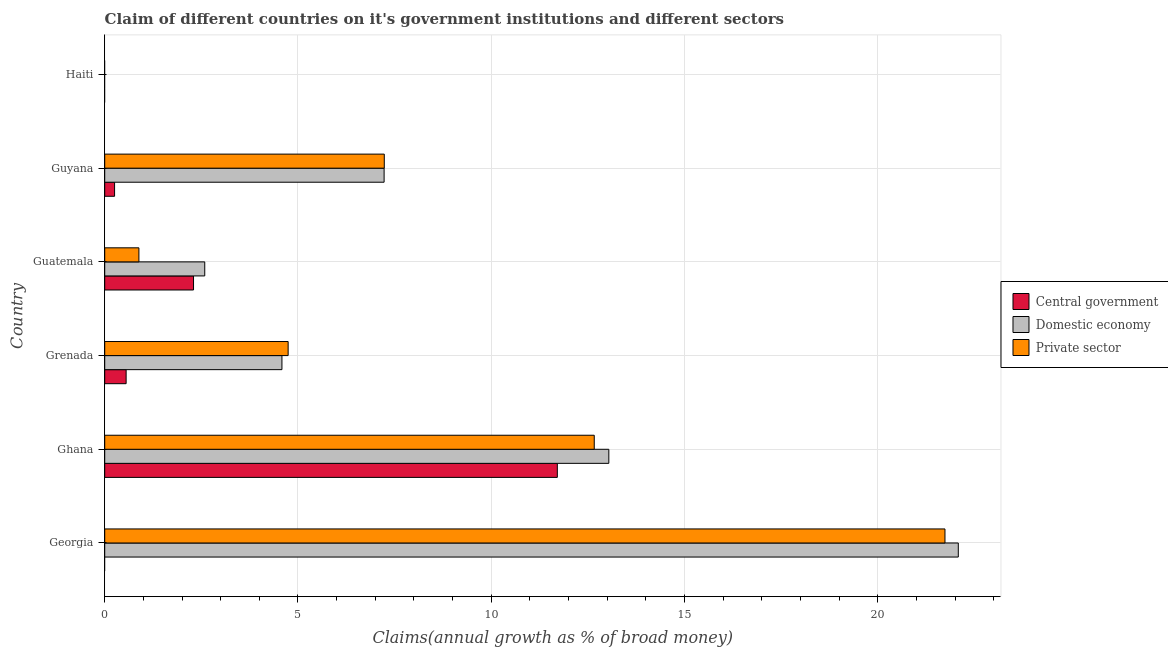How many different coloured bars are there?
Provide a short and direct response. 3. Are the number of bars on each tick of the Y-axis equal?
Your answer should be very brief. No. What is the label of the 2nd group of bars from the top?
Keep it short and to the point. Guyana. What is the percentage of claim on the central government in Haiti?
Your answer should be very brief. 0. Across all countries, what is the maximum percentage of claim on the private sector?
Offer a very short reply. 21.74. Across all countries, what is the minimum percentage of claim on the private sector?
Keep it short and to the point. 0. In which country was the percentage of claim on the private sector maximum?
Ensure brevity in your answer.  Georgia. What is the total percentage of claim on the private sector in the graph?
Make the answer very short. 47.27. What is the difference between the percentage of claim on the private sector in Ghana and that in Guyana?
Your answer should be compact. 5.43. What is the difference between the percentage of claim on the private sector in Grenada and the percentage of claim on the domestic economy in Georgia?
Ensure brevity in your answer.  -17.34. What is the average percentage of claim on the private sector per country?
Keep it short and to the point. 7.88. What is the difference between the percentage of claim on the private sector and percentage of claim on the central government in Grenada?
Provide a succinct answer. 4.19. What is the ratio of the percentage of claim on the domestic economy in Grenada to that in Guatemala?
Your answer should be compact. 1.77. Is the percentage of claim on the domestic economy in Ghana less than that in Guatemala?
Your answer should be compact. No. What is the difference between the highest and the second highest percentage of claim on the central government?
Your answer should be compact. 9.41. What is the difference between the highest and the lowest percentage of claim on the private sector?
Give a very brief answer. 21.74. In how many countries, is the percentage of claim on the private sector greater than the average percentage of claim on the private sector taken over all countries?
Provide a short and direct response. 2. Is it the case that in every country, the sum of the percentage of claim on the central government and percentage of claim on the domestic economy is greater than the percentage of claim on the private sector?
Your answer should be very brief. No. Are all the bars in the graph horizontal?
Keep it short and to the point. Yes. How many countries are there in the graph?
Provide a short and direct response. 6. Are the values on the major ticks of X-axis written in scientific E-notation?
Keep it short and to the point. No. Does the graph contain grids?
Provide a succinct answer. Yes. How many legend labels are there?
Your response must be concise. 3. What is the title of the graph?
Keep it short and to the point. Claim of different countries on it's government institutions and different sectors. Does "Refusal of sex" appear as one of the legend labels in the graph?
Make the answer very short. No. What is the label or title of the X-axis?
Offer a terse response. Claims(annual growth as % of broad money). What is the label or title of the Y-axis?
Offer a very short reply. Country. What is the Claims(annual growth as % of broad money) of Central government in Georgia?
Your answer should be compact. 0. What is the Claims(annual growth as % of broad money) in Domestic economy in Georgia?
Give a very brief answer. 22.08. What is the Claims(annual growth as % of broad money) in Private sector in Georgia?
Ensure brevity in your answer.  21.74. What is the Claims(annual growth as % of broad money) in Central government in Ghana?
Your answer should be compact. 11.71. What is the Claims(annual growth as % of broad money) of Domestic economy in Ghana?
Provide a succinct answer. 13.04. What is the Claims(annual growth as % of broad money) in Private sector in Ghana?
Your answer should be very brief. 12.66. What is the Claims(annual growth as % of broad money) of Central government in Grenada?
Offer a terse response. 0.55. What is the Claims(annual growth as % of broad money) of Domestic economy in Grenada?
Your answer should be compact. 4.58. What is the Claims(annual growth as % of broad money) in Private sector in Grenada?
Keep it short and to the point. 4.75. What is the Claims(annual growth as % of broad money) in Central government in Guatemala?
Make the answer very short. 2.3. What is the Claims(annual growth as % of broad money) of Domestic economy in Guatemala?
Offer a terse response. 2.59. What is the Claims(annual growth as % of broad money) in Private sector in Guatemala?
Provide a succinct answer. 0.88. What is the Claims(annual growth as % of broad money) of Central government in Guyana?
Keep it short and to the point. 0.25. What is the Claims(annual growth as % of broad money) of Domestic economy in Guyana?
Ensure brevity in your answer.  7.23. What is the Claims(annual growth as % of broad money) in Private sector in Guyana?
Ensure brevity in your answer.  7.23. What is the Claims(annual growth as % of broad money) of Private sector in Haiti?
Your answer should be very brief. 0. Across all countries, what is the maximum Claims(annual growth as % of broad money) of Central government?
Give a very brief answer. 11.71. Across all countries, what is the maximum Claims(annual growth as % of broad money) in Domestic economy?
Make the answer very short. 22.08. Across all countries, what is the maximum Claims(annual growth as % of broad money) in Private sector?
Make the answer very short. 21.74. Across all countries, what is the minimum Claims(annual growth as % of broad money) of Central government?
Your answer should be compact. 0. What is the total Claims(annual growth as % of broad money) of Central government in the graph?
Your response must be concise. 14.82. What is the total Claims(annual growth as % of broad money) of Domestic economy in the graph?
Offer a terse response. 49.53. What is the total Claims(annual growth as % of broad money) in Private sector in the graph?
Your answer should be compact. 47.27. What is the difference between the Claims(annual growth as % of broad money) in Domestic economy in Georgia and that in Ghana?
Offer a terse response. 9.04. What is the difference between the Claims(annual growth as % of broad money) of Private sector in Georgia and that in Ghana?
Offer a very short reply. 9.07. What is the difference between the Claims(annual growth as % of broad money) of Domestic economy in Georgia and that in Grenada?
Give a very brief answer. 17.5. What is the difference between the Claims(annual growth as % of broad money) in Private sector in Georgia and that in Grenada?
Provide a short and direct response. 16.99. What is the difference between the Claims(annual growth as % of broad money) of Domestic economy in Georgia and that in Guatemala?
Offer a terse response. 19.49. What is the difference between the Claims(annual growth as % of broad money) of Private sector in Georgia and that in Guatemala?
Offer a terse response. 20.85. What is the difference between the Claims(annual growth as % of broad money) in Domestic economy in Georgia and that in Guyana?
Ensure brevity in your answer.  14.85. What is the difference between the Claims(annual growth as % of broad money) of Private sector in Georgia and that in Guyana?
Offer a very short reply. 14.51. What is the difference between the Claims(annual growth as % of broad money) in Central government in Ghana and that in Grenada?
Provide a succinct answer. 11.16. What is the difference between the Claims(annual growth as % of broad money) in Domestic economy in Ghana and that in Grenada?
Make the answer very short. 8.46. What is the difference between the Claims(annual growth as % of broad money) of Private sector in Ghana and that in Grenada?
Provide a short and direct response. 7.92. What is the difference between the Claims(annual growth as % of broad money) in Central government in Ghana and that in Guatemala?
Keep it short and to the point. 9.41. What is the difference between the Claims(annual growth as % of broad money) of Domestic economy in Ghana and that in Guatemala?
Offer a very short reply. 10.45. What is the difference between the Claims(annual growth as % of broad money) in Private sector in Ghana and that in Guatemala?
Your answer should be very brief. 11.78. What is the difference between the Claims(annual growth as % of broad money) of Central government in Ghana and that in Guyana?
Your answer should be very brief. 11.45. What is the difference between the Claims(annual growth as % of broad money) of Domestic economy in Ghana and that in Guyana?
Offer a very short reply. 5.81. What is the difference between the Claims(annual growth as % of broad money) in Private sector in Ghana and that in Guyana?
Ensure brevity in your answer.  5.43. What is the difference between the Claims(annual growth as % of broad money) in Central government in Grenada and that in Guatemala?
Offer a very short reply. -1.74. What is the difference between the Claims(annual growth as % of broad money) of Domestic economy in Grenada and that in Guatemala?
Offer a very short reply. 2. What is the difference between the Claims(annual growth as % of broad money) in Private sector in Grenada and that in Guatemala?
Your answer should be compact. 3.86. What is the difference between the Claims(annual growth as % of broad money) in Central government in Grenada and that in Guyana?
Your response must be concise. 0.3. What is the difference between the Claims(annual growth as % of broad money) in Domestic economy in Grenada and that in Guyana?
Offer a terse response. -2.64. What is the difference between the Claims(annual growth as % of broad money) in Private sector in Grenada and that in Guyana?
Your answer should be very brief. -2.49. What is the difference between the Claims(annual growth as % of broad money) of Central government in Guatemala and that in Guyana?
Make the answer very short. 2.04. What is the difference between the Claims(annual growth as % of broad money) of Domestic economy in Guatemala and that in Guyana?
Ensure brevity in your answer.  -4.64. What is the difference between the Claims(annual growth as % of broad money) of Private sector in Guatemala and that in Guyana?
Your response must be concise. -6.35. What is the difference between the Claims(annual growth as % of broad money) in Domestic economy in Georgia and the Claims(annual growth as % of broad money) in Private sector in Ghana?
Make the answer very short. 9.42. What is the difference between the Claims(annual growth as % of broad money) in Domestic economy in Georgia and the Claims(annual growth as % of broad money) in Private sector in Grenada?
Your response must be concise. 17.34. What is the difference between the Claims(annual growth as % of broad money) in Domestic economy in Georgia and the Claims(annual growth as % of broad money) in Private sector in Guatemala?
Offer a very short reply. 21.2. What is the difference between the Claims(annual growth as % of broad money) in Domestic economy in Georgia and the Claims(annual growth as % of broad money) in Private sector in Guyana?
Offer a very short reply. 14.85. What is the difference between the Claims(annual growth as % of broad money) of Central government in Ghana and the Claims(annual growth as % of broad money) of Domestic economy in Grenada?
Keep it short and to the point. 7.12. What is the difference between the Claims(annual growth as % of broad money) of Central government in Ghana and the Claims(annual growth as % of broad money) of Private sector in Grenada?
Offer a terse response. 6.96. What is the difference between the Claims(annual growth as % of broad money) in Domestic economy in Ghana and the Claims(annual growth as % of broad money) in Private sector in Grenada?
Offer a terse response. 8.3. What is the difference between the Claims(annual growth as % of broad money) of Central government in Ghana and the Claims(annual growth as % of broad money) of Domestic economy in Guatemala?
Offer a terse response. 9.12. What is the difference between the Claims(annual growth as % of broad money) in Central government in Ghana and the Claims(annual growth as % of broad money) in Private sector in Guatemala?
Offer a terse response. 10.82. What is the difference between the Claims(annual growth as % of broad money) in Domestic economy in Ghana and the Claims(annual growth as % of broad money) in Private sector in Guatemala?
Provide a short and direct response. 12.16. What is the difference between the Claims(annual growth as % of broad money) in Central government in Ghana and the Claims(annual growth as % of broad money) in Domestic economy in Guyana?
Provide a succinct answer. 4.48. What is the difference between the Claims(annual growth as % of broad money) in Central government in Ghana and the Claims(annual growth as % of broad money) in Private sector in Guyana?
Your answer should be very brief. 4.48. What is the difference between the Claims(annual growth as % of broad money) in Domestic economy in Ghana and the Claims(annual growth as % of broad money) in Private sector in Guyana?
Provide a short and direct response. 5.81. What is the difference between the Claims(annual growth as % of broad money) in Central government in Grenada and the Claims(annual growth as % of broad money) in Domestic economy in Guatemala?
Keep it short and to the point. -2.03. What is the difference between the Claims(annual growth as % of broad money) in Central government in Grenada and the Claims(annual growth as % of broad money) in Private sector in Guatemala?
Your response must be concise. -0.33. What is the difference between the Claims(annual growth as % of broad money) of Domestic economy in Grenada and the Claims(annual growth as % of broad money) of Private sector in Guatemala?
Offer a terse response. 3.7. What is the difference between the Claims(annual growth as % of broad money) in Central government in Grenada and the Claims(annual growth as % of broad money) in Domestic economy in Guyana?
Your answer should be compact. -6.67. What is the difference between the Claims(annual growth as % of broad money) in Central government in Grenada and the Claims(annual growth as % of broad money) in Private sector in Guyana?
Provide a succinct answer. -6.68. What is the difference between the Claims(annual growth as % of broad money) of Domestic economy in Grenada and the Claims(annual growth as % of broad money) of Private sector in Guyana?
Make the answer very short. -2.65. What is the difference between the Claims(annual growth as % of broad money) of Central government in Guatemala and the Claims(annual growth as % of broad money) of Domestic economy in Guyana?
Provide a succinct answer. -4.93. What is the difference between the Claims(annual growth as % of broad money) in Central government in Guatemala and the Claims(annual growth as % of broad money) in Private sector in Guyana?
Your response must be concise. -4.93. What is the difference between the Claims(annual growth as % of broad money) in Domestic economy in Guatemala and the Claims(annual growth as % of broad money) in Private sector in Guyana?
Provide a succinct answer. -4.64. What is the average Claims(annual growth as % of broad money) in Central government per country?
Provide a succinct answer. 2.47. What is the average Claims(annual growth as % of broad money) of Domestic economy per country?
Offer a terse response. 8.25. What is the average Claims(annual growth as % of broad money) in Private sector per country?
Your answer should be very brief. 7.88. What is the difference between the Claims(annual growth as % of broad money) in Domestic economy and Claims(annual growth as % of broad money) in Private sector in Georgia?
Offer a very short reply. 0.34. What is the difference between the Claims(annual growth as % of broad money) of Central government and Claims(annual growth as % of broad money) of Domestic economy in Ghana?
Provide a short and direct response. -1.33. What is the difference between the Claims(annual growth as % of broad money) of Central government and Claims(annual growth as % of broad money) of Private sector in Ghana?
Your response must be concise. -0.95. What is the difference between the Claims(annual growth as % of broad money) in Domestic economy and Claims(annual growth as % of broad money) in Private sector in Ghana?
Your answer should be very brief. 0.38. What is the difference between the Claims(annual growth as % of broad money) of Central government and Claims(annual growth as % of broad money) of Domestic economy in Grenada?
Your answer should be very brief. -4.03. What is the difference between the Claims(annual growth as % of broad money) in Central government and Claims(annual growth as % of broad money) in Private sector in Grenada?
Offer a very short reply. -4.19. What is the difference between the Claims(annual growth as % of broad money) in Domestic economy and Claims(annual growth as % of broad money) in Private sector in Grenada?
Keep it short and to the point. -0.16. What is the difference between the Claims(annual growth as % of broad money) of Central government and Claims(annual growth as % of broad money) of Domestic economy in Guatemala?
Offer a terse response. -0.29. What is the difference between the Claims(annual growth as % of broad money) of Central government and Claims(annual growth as % of broad money) of Private sector in Guatemala?
Give a very brief answer. 1.41. What is the difference between the Claims(annual growth as % of broad money) of Domestic economy and Claims(annual growth as % of broad money) of Private sector in Guatemala?
Provide a succinct answer. 1.7. What is the difference between the Claims(annual growth as % of broad money) in Central government and Claims(annual growth as % of broad money) in Domestic economy in Guyana?
Offer a terse response. -6.97. What is the difference between the Claims(annual growth as % of broad money) in Central government and Claims(annual growth as % of broad money) in Private sector in Guyana?
Your answer should be very brief. -6.98. What is the difference between the Claims(annual growth as % of broad money) of Domestic economy and Claims(annual growth as % of broad money) of Private sector in Guyana?
Your answer should be very brief. -0. What is the ratio of the Claims(annual growth as % of broad money) of Domestic economy in Georgia to that in Ghana?
Your answer should be very brief. 1.69. What is the ratio of the Claims(annual growth as % of broad money) of Private sector in Georgia to that in Ghana?
Your answer should be compact. 1.72. What is the ratio of the Claims(annual growth as % of broad money) in Domestic economy in Georgia to that in Grenada?
Provide a succinct answer. 4.82. What is the ratio of the Claims(annual growth as % of broad money) in Private sector in Georgia to that in Grenada?
Your answer should be very brief. 4.58. What is the ratio of the Claims(annual growth as % of broad money) in Domestic economy in Georgia to that in Guatemala?
Your answer should be very brief. 8.53. What is the ratio of the Claims(annual growth as % of broad money) in Private sector in Georgia to that in Guatemala?
Provide a short and direct response. 24.57. What is the ratio of the Claims(annual growth as % of broad money) in Domestic economy in Georgia to that in Guyana?
Your answer should be very brief. 3.06. What is the ratio of the Claims(annual growth as % of broad money) of Private sector in Georgia to that in Guyana?
Your answer should be very brief. 3.01. What is the ratio of the Claims(annual growth as % of broad money) in Central government in Ghana to that in Grenada?
Your answer should be very brief. 21.14. What is the ratio of the Claims(annual growth as % of broad money) of Domestic economy in Ghana to that in Grenada?
Ensure brevity in your answer.  2.84. What is the ratio of the Claims(annual growth as % of broad money) in Private sector in Ghana to that in Grenada?
Offer a very short reply. 2.67. What is the ratio of the Claims(annual growth as % of broad money) of Central government in Ghana to that in Guatemala?
Your response must be concise. 5.1. What is the ratio of the Claims(annual growth as % of broad money) in Domestic economy in Ghana to that in Guatemala?
Your response must be concise. 5.04. What is the ratio of the Claims(annual growth as % of broad money) of Private sector in Ghana to that in Guatemala?
Give a very brief answer. 14.32. What is the ratio of the Claims(annual growth as % of broad money) in Central government in Ghana to that in Guyana?
Your answer should be very brief. 45.93. What is the ratio of the Claims(annual growth as % of broad money) of Domestic economy in Ghana to that in Guyana?
Offer a very short reply. 1.8. What is the ratio of the Claims(annual growth as % of broad money) of Private sector in Ghana to that in Guyana?
Your response must be concise. 1.75. What is the ratio of the Claims(annual growth as % of broad money) of Central government in Grenada to that in Guatemala?
Provide a short and direct response. 0.24. What is the ratio of the Claims(annual growth as % of broad money) of Domestic economy in Grenada to that in Guatemala?
Provide a succinct answer. 1.77. What is the ratio of the Claims(annual growth as % of broad money) in Private sector in Grenada to that in Guatemala?
Keep it short and to the point. 5.36. What is the ratio of the Claims(annual growth as % of broad money) of Central government in Grenada to that in Guyana?
Offer a very short reply. 2.17. What is the ratio of the Claims(annual growth as % of broad money) of Domestic economy in Grenada to that in Guyana?
Your answer should be very brief. 0.63. What is the ratio of the Claims(annual growth as % of broad money) of Private sector in Grenada to that in Guyana?
Ensure brevity in your answer.  0.66. What is the ratio of the Claims(annual growth as % of broad money) of Central government in Guatemala to that in Guyana?
Your response must be concise. 9.01. What is the ratio of the Claims(annual growth as % of broad money) in Domestic economy in Guatemala to that in Guyana?
Offer a very short reply. 0.36. What is the ratio of the Claims(annual growth as % of broad money) of Private sector in Guatemala to that in Guyana?
Ensure brevity in your answer.  0.12. What is the difference between the highest and the second highest Claims(annual growth as % of broad money) of Central government?
Keep it short and to the point. 9.41. What is the difference between the highest and the second highest Claims(annual growth as % of broad money) in Domestic economy?
Keep it short and to the point. 9.04. What is the difference between the highest and the second highest Claims(annual growth as % of broad money) in Private sector?
Make the answer very short. 9.07. What is the difference between the highest and the lowest Claims(annual growth as % of broad money) in Central government?
Offer a terse response. 11.71. What is the difference between the highest and the lowest Claims(annual growth as % of broad money) in Domestic economy?
Provide a succinct answer. 22.08. What is the difference between the highest and the lowest Claims(annual growth as % of broad money) in Private sector?
Your response must be concise. 21.74. 